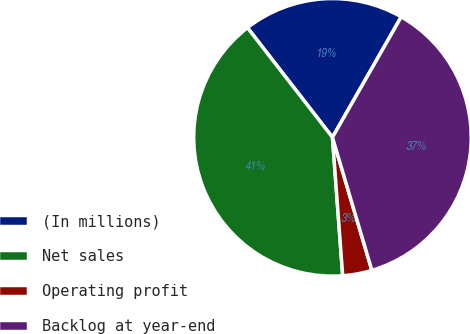<chart> <loc_0><loc_0><loc_500><loc_500><pie_chart><fcel>(In millions)<fcel>Net sales<fcel>Operating profit<fcel>Backlog at year-end<nl><fcel>18.75%<fcel>40.68%<fcel>3.41%<fcel>37.16%<nl></chart> 